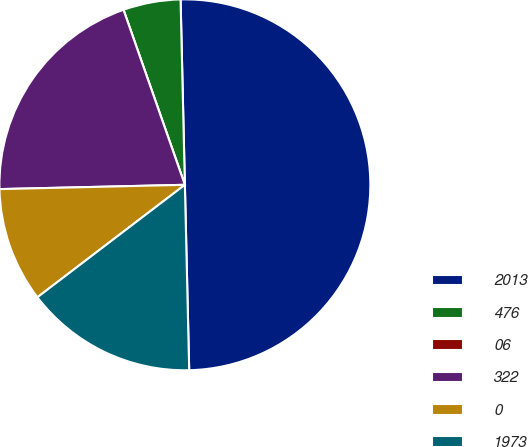Convert chart. <chart><loc_0><loc_0><loc_500><loc_500><pie_chart><fcel>2013<fcel>476<fcel>06<fcel>322<fcel>0<fcel>1973<nl><fcel>50.0%<fcel>5.0%<fcel>0.0%<fcel>20.0%<fcel>10.0%<fcel>15.0%<nl></chart> 